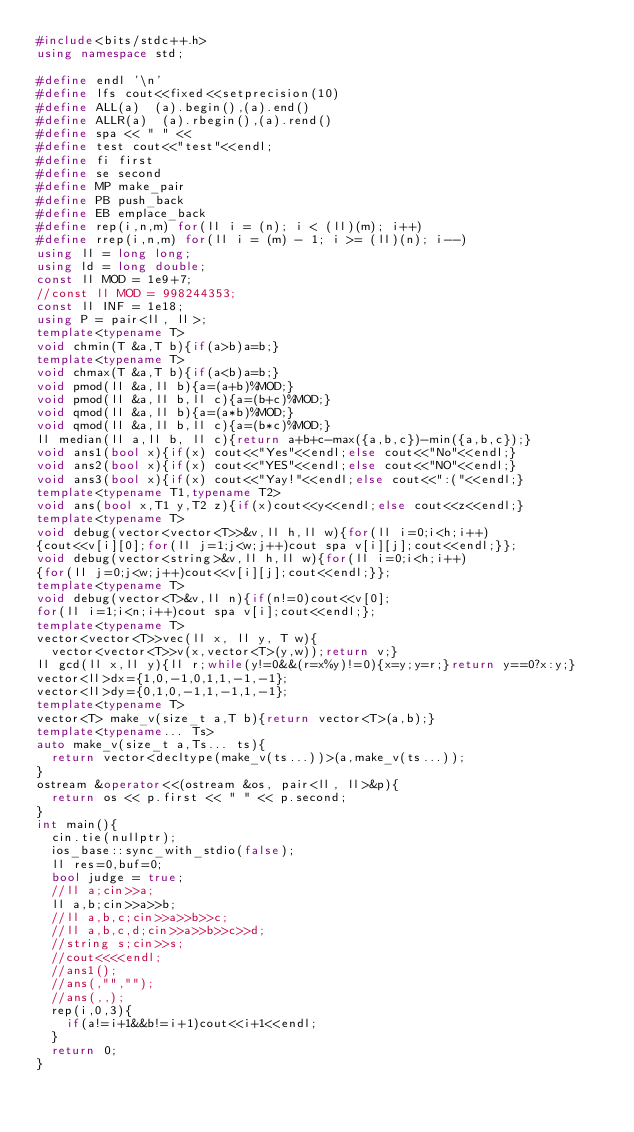<code> <loc_0><loc_0><loc_500><loc_500><_C++_>#include<bits/stdc++.h>
using namespace std;

#define endl '\n'
#define lfs cout<<fixed<<setprecision(10)
#define ALL(a)  (a).begin(),(a).end()
#define ALLR(a)  (a).rbegin(),(a).rend()
#define spa << " " <<
#define test cout<<"test"<<endl;
#define fi first
#define se second
#define MP make_pair
#define PB push_back
#define EB emplace_back
#define rep(i,n,m) for(ll i = (n); i < (ll)(m); i++)
#define rrep(i,n,m) for(ll i = (m) - 1; i >= (ll)(n); i--)
using ll = long long;
using ld = long double;
const ll MOD = 1e9+7;
//const ll MOD = 998244353;
const ll INF = 1e18;
using P = pair<ll, ll>;
template<typename T>
void chmin(T &a,T b){if(a>b)a=b;}
template<typename T>
void chmax(T &a,T b){if(a<b)a=b;}
void pmod(ll &a,ll b){a=(a+b)%MOD;}
void pmod(ll &a,ll b,ll c){a=(b+c)%MOD;}
void qmod(ll &a,ll b){a=(a*b)%MOD;}
void qmod(ll &a,ll b,ll c){a=(b*c)%MOD;}
ll median(ll a,ll b, ll c){return a+b+c-max({a,b,c})-min({a,b,c});}
void ans1(bool x){if(x) cout<<"Yes"<<endl;else cout<<"No"<<endl;}
void ans2(bool x){if(x) cout<<"YES"<<endl;else cout<<"NO"<<endl;}
void ans3(bool x){if(x) cout<<"Yay!"<<endl;else cout<<":("<<endl;}
template<typename T1,typename T2>
void ans(bool x,T1 y,T2 z){if(x)cout<<y<<endl;else cout<<z<<endl;}  
template<typename T>
void debug(vector<vector<T>>&v,ll h,ll w){for(ll i=0;i<h;i++)
{cout<<v[i][0];for(ll j=1;j<w;j++)cout spa v[i][j];cout<<endl;}};
void debug(vector<string>&v,ll h,ll w){for(ll i=0;i<h;i++)
{for(ll j=0;j<w;j++)cout<<v[i][j];cout<<endl;}};
template<typename T>
void debug(vector<T>&v,ll n){if(n!=0)cout<<v[0];
for(ll i=1;i<n;i++)cout spa v[i];cout<<endl;};
template<typename T>
vector<vector<T>>vec(ll x, ll y, T w){
  vector<vector<T>>v(x,vector<T>(y,w));return v;}
ll gcd(ll x,ll y){ll r;while(y!=0&&(r=x%y)!=0){x=y;y=r;}return y==0?x:y;}
vector<ll>dx={1,0,-1,0,1,1,-1,-1};
vector<ll>dy={0,1,0,-1,1,-1,1,-1};
template<typename T>
vector<T> make_v(size_t a,T b){return vector<T>(a,b);}
template<typename... Ts>
auto make_v(size_t a,Ts... ts){
  return vector<decltype(make_v(ts...))>(a,make_v(ts...));
}
ostream &operator<<(ostream &os, pair<ll, ll>&p){
  return os << p.first << " " << p.second;
}  
int main(){
  cin.tie(nullptr);
  ios_base::sync_with_stdio(false);
  ll res=0,buf=0;
  bool judge = true;
  //ll a;cin>>a;
  ll a,b;cin>>a>>b;
  //ll a,b,c;cin>>a>>b>>c;
  //ll a,b,c,d;cin>>a>>b>>c>>d;
  //string s;cin>>s;
  //cout<<<<endl;
  //ans1();
  //ans(,"","");
  //ans(,,);
  rep(i,0,3){
    if(a!=i+1&&b!=i+1)cout<<i+1<<endl;
  }
  return 0;
}</code> 